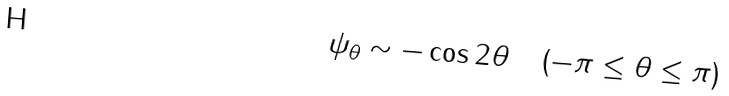Convert formula to latex. <formula><loc_0><loc_0><loc_500><loc_500>\begin{array} { l c r } { \psi _ { \theta } \sim - \cos 2 \theta } & & { ( - \pi \leq \theta \leq \pi ) } \end{array}</formula> 